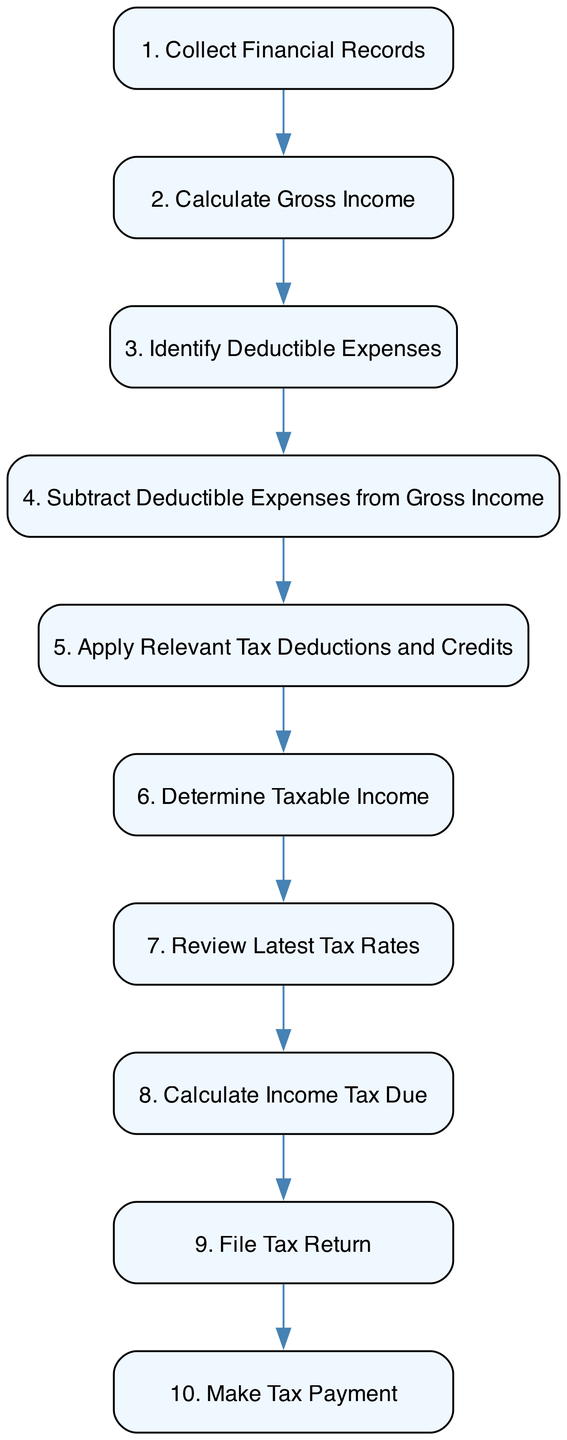What is the first step in calculating taxable income? The first step is described in the diagram as "Collect Financial Records," where the entrepreneur gathers all necessary financial documents.
Answer: Collect Financial Records How many total steps are there in this process? By counting the steps numbered from 1 to 10 in the diagram, we find that there are a total of 10 steps listed for calculating taxable income.
Answer: 10 What comes after "Identify Deductible Expenses"? In the flowchart, after the step "Identify Deductible Expenses," the next step is "Subtract Deductible Expenses from Gross Income," indicating the process of calculating net income.
Answer: Subtract Deductible Expenses from Gross Income Which step involves applying specific tax deductions? The step that involves applying specific tax deductions and credits is "Apply Relevant Tax Deductions and Credits." This is where the entrepreneur identifies applicable deductions for their business.
Answer: Apply Relevant Tax Deductions and Credits What is the final step in the process outlined in the diagram? The final step in the process is "Make Tax Payment," indicating that after filing the return, the entrepreneur needs to pay the calculated tax.
Answer: Make Tax Payment What must be done before determining taxable income? Before determining taxable income, the entrepreneur must "Apply Relevant Tax Deductions and Credits," which involves the application of applicable deductions to the calculated figure.
Answer: Apply Relevant Tax Deductions and Credits How do you get from calculating gross income to filing a tax return? The process flows from "Calculate Gross Income" to "Determine Taxable Income," then to "Review Latest Tax Rates," followed by "Calculate Income Tax Due," and finally ends with "File Tax Return." Thus, these steps contribute sequentially to reach the filing stage.
Answer: Through steps: Calculate Gross Income → Determine Taxable Income → Review Latest Tax Rates → Calculate Income Tax Due → File Tax Return What authority's website should entrepreneurs refer to for current tax rates? Entrepreneurs should refer to the "French Tax Administration (Direction Générale des Finances Publiques)" website to access the latest tax rates applicable to their income.
Answer: French Tax Administration What is the second step in the diagram? The second step in the diagram is "Calculate Gross Income," which entails adding everything earned from various business activities.
Answer: Calculate Gross Income What action follows "Review Latest Tax Rates"? The action that follows "Review Latest Tax Rates" is "Calculate Income Tax Due," where the entrepreneur then applies the applicable tax rate to their taxable income.
Answer: Calculate Income Tax Due 